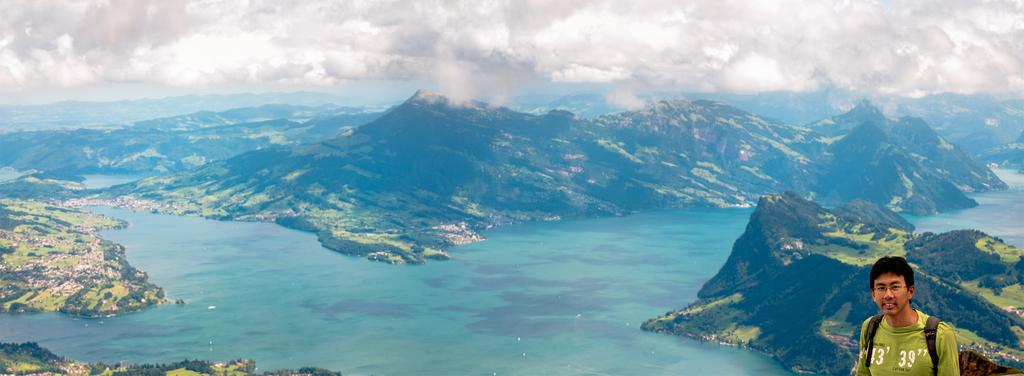What is the main feature of the image? The main feature of the image is water. What other natural elements can be seen in the image? There are mountains and a group of trees in the image. Is there any sign of human presence in the image? Yes, there is a person in the bottom right corner of the image. What is visible at the top of the image? The sky is visible at the top of the image. What type of connection can be seen between the mountains and the hospital in the image? There is no hospital present in the image, and therefore no connection can be observed between the mountains and a hospital. 